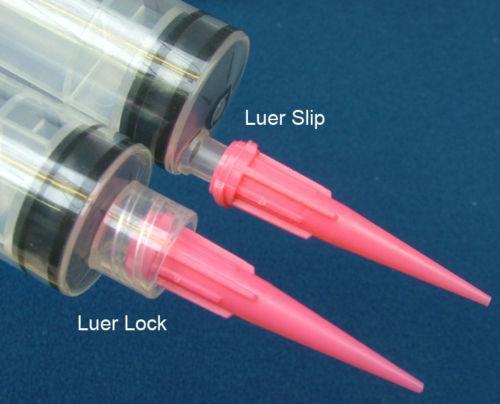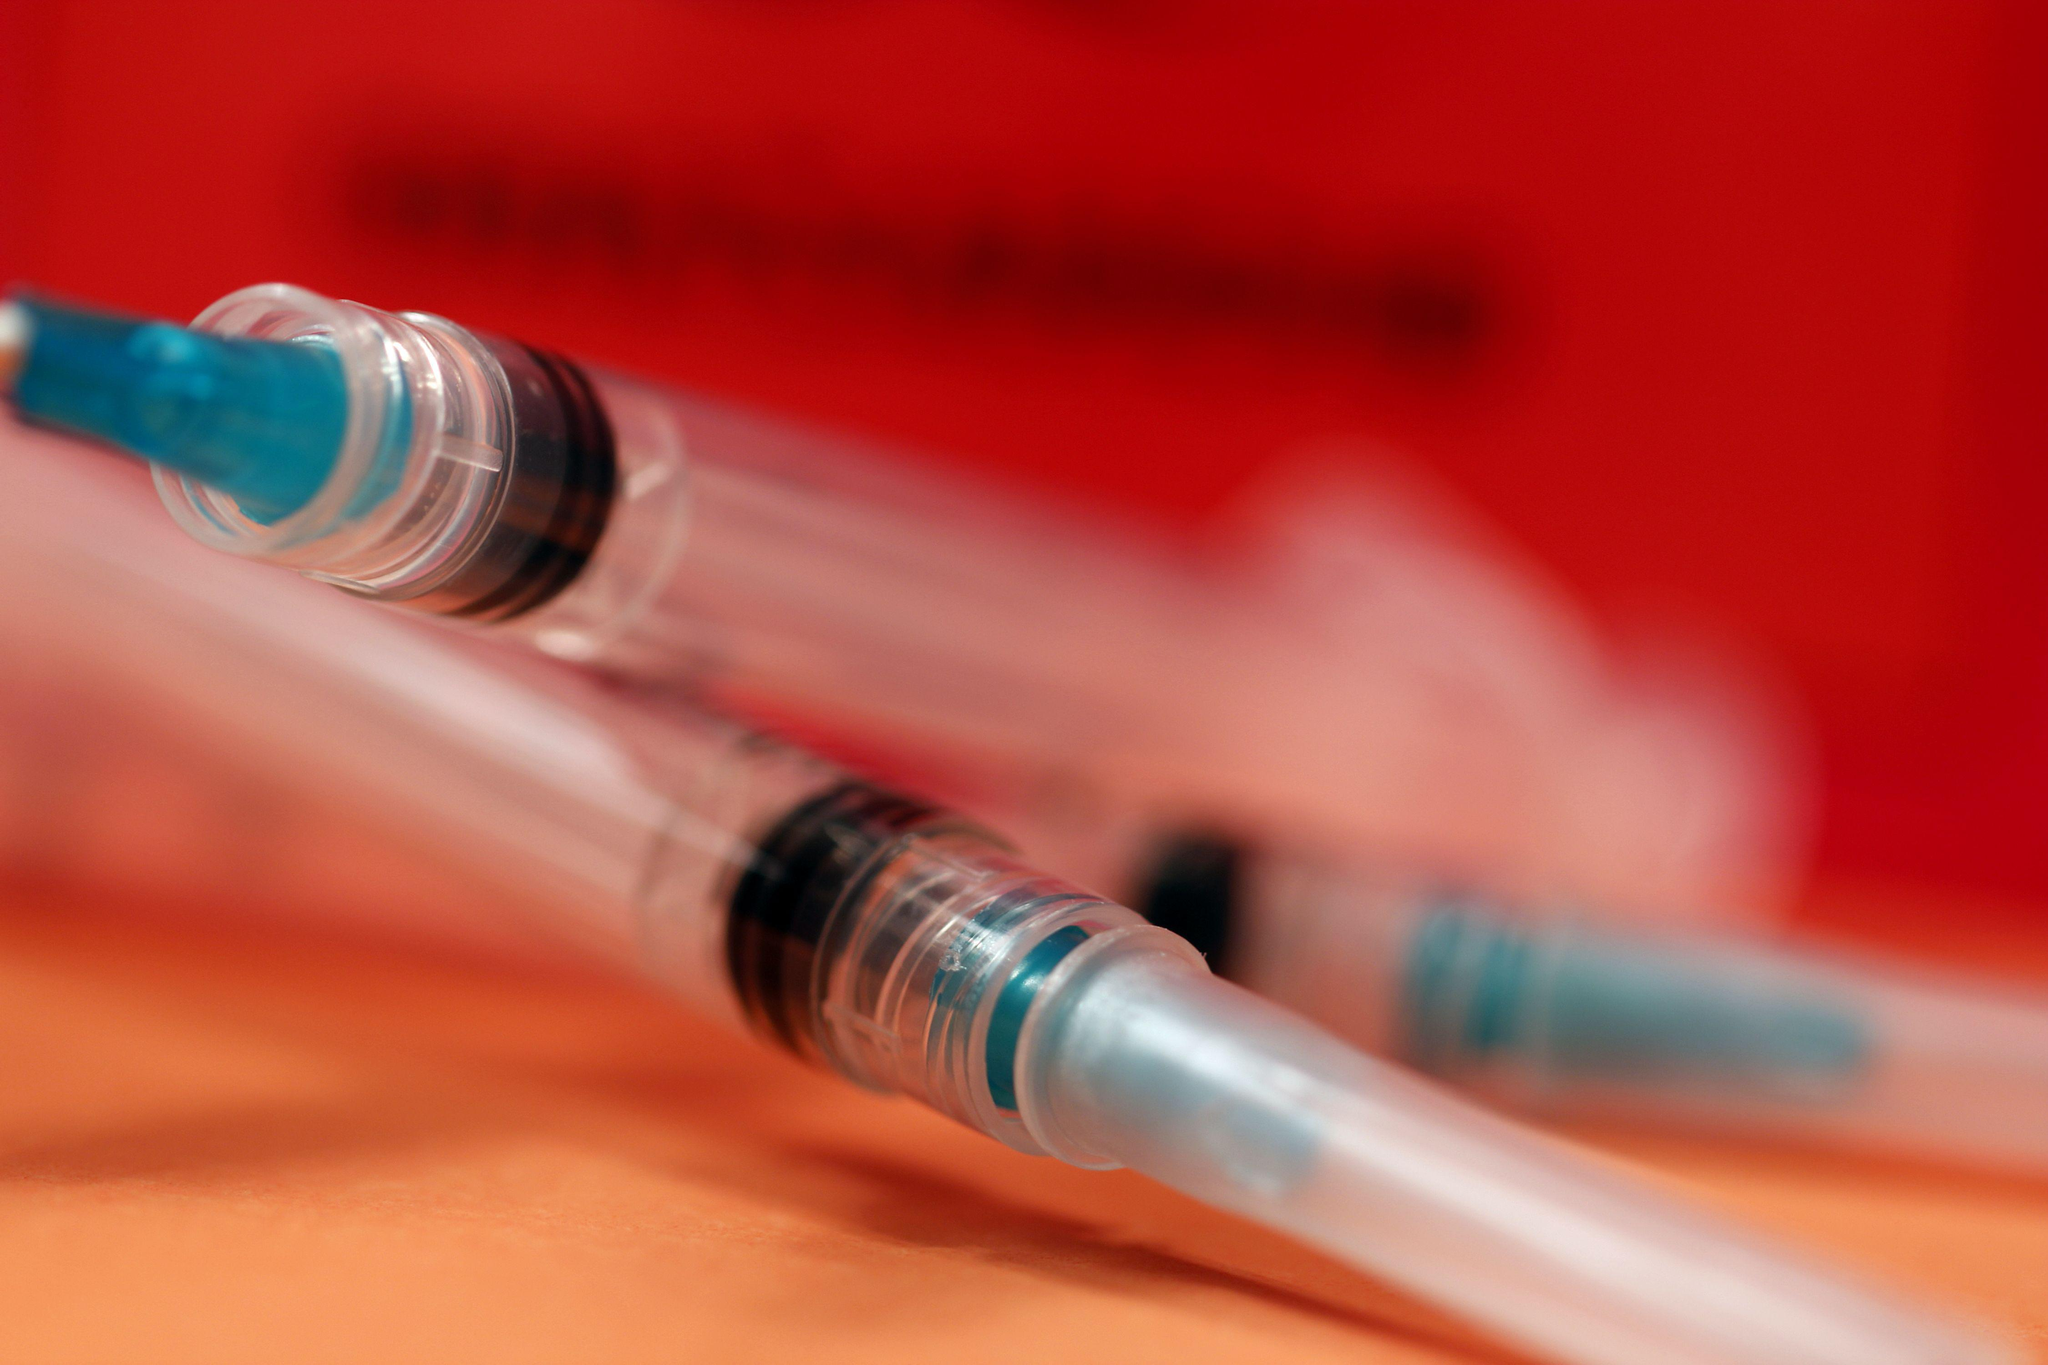The first image is the image on the left, the second image is the image on the right. Examine the images to the left and right. Is the description "At least one syringe in the image on the left has a pink tip." accurate? Answer yes or no. Yes. 